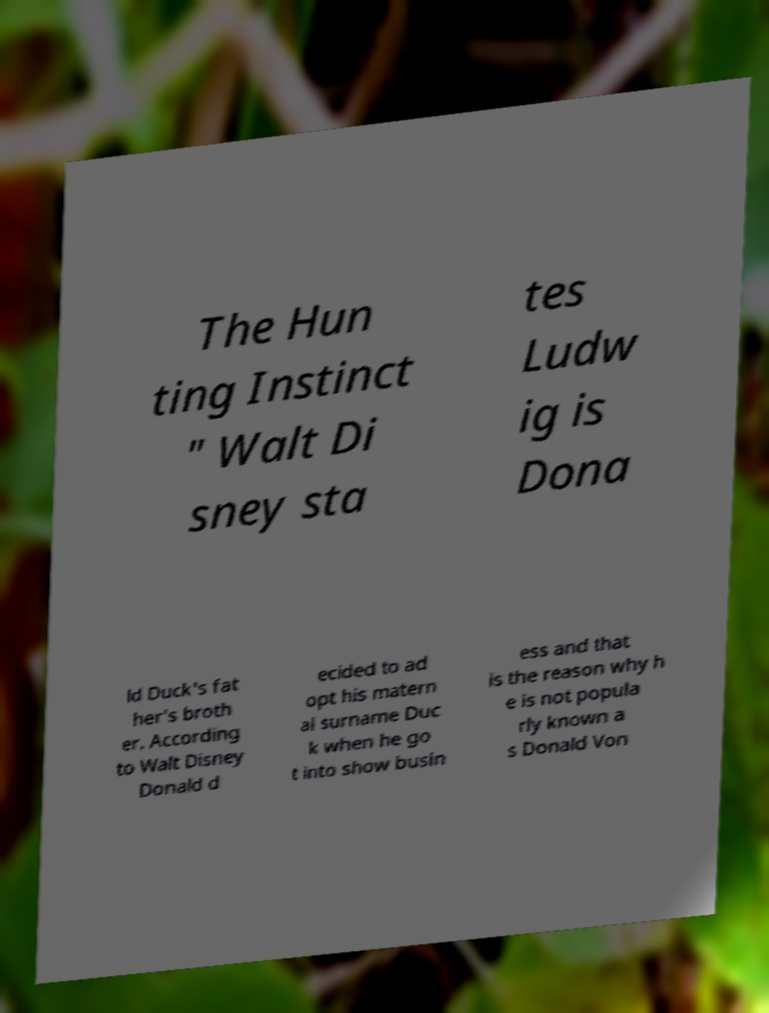There's text embedded in this image that I need extracted. Can you transcribe it verbatim? The Hun ting Instinct " Walt Di sney sta tes Ludw ig is Dona ld Duck's fat her's broth er. According to Walt Disney Donald d ecided to ad opt his matern al surname Duc k when he go t into show busin ess and that is the reason why h e is not popula rly known a s Donald Von 